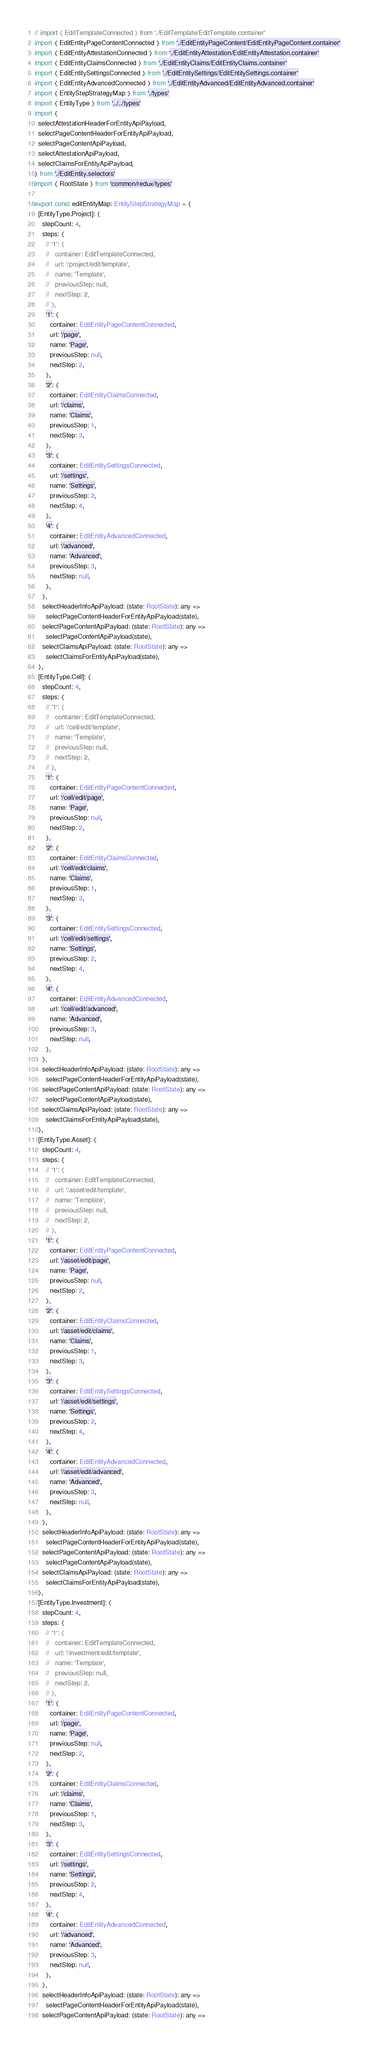<code> <loc_0><loc_0><loc_500><loc_500><_TypeScript_>// import { EditTemplateConnected } from './EditTemplate/EditTemplate.container'
import { EditEntityPageContentConnected } from './EditEntityPageContent/EditEntityPageContent.container'
import { EditEntityAttestationConnected } from './EditEntityAttestation/EditEntityAttestation.container'
import { EditEntityClaimsConnected } from './EditEntityClaims/EditEntityClaims.container'
import { EditEntitySettingsConnected } from './EditEntitySettings/EditEntitySettings.container'
import { EditEntityAdvancedConnected } from './EditEntityAdvanced/EditEntityAdvanced.container'
import { EntityStepStrategyMap } from './types'
import { EntityType } from '../../types'
import {
  selectAttestationHeaderForEntityApiPayload,
  selectPageContentHeaderForEntityApiPayload,
  selectPageContentApiPayload,
  selectAttestationApiPayload,
  selectClaimsForEntityApiPayload,
} from './EditEntity.selectors'
import { RootState } from 'common/redux/types'

export const editEntityMap: EntityStepStrategyMap = {
  [EntityType.Project]: {
    stepCount: 4,
    steps: {
      // '1': {
      //   container: EditTemplateConnected,
      //   url: '/project/edit/template',
      //   name: 'Template',
      //   previousStep: null,
      //   nextStep: 2,
      // },
      '1': {
        container: EditEntityPageContentConnected,
        url: '/page',
        name: 'Page',
        previousStep: null,
        nextStep: 2,
      },
      '2': {
        container: EditEntityClaimsConnected,
        url: '/claims',
        name: 'Claims',
        previousStep: 1,
        nextStep: 3,
      },
      '3': {
        container: EditEntitySettingsConnected,
        url: '/settings',
        name: 'Settings',
        previousStep: 2,
        nextStep: 4,
      },
      '4': {
        container: EditEntityAdvancedConnected,
        url: '/advanced',
        name: 'Advanced',
        previousStep: 3,
        nextStep: null,
      },
    },
    selectHeaderInfoApiPayload: (state: RootState): any =>
      selectPageContentHeaderForEntityApiPayload(state),
    selectPageContentApiPayload: (state: RootState): any =>
      selectPageContentApiPayload(state),
    selectClaimsApiPayload: (state: RootState): any =>
      selectClaimsForEntityApiPayload(state),
  },
  [EntityType.Cell]: {
    stepCount: 4,
    steps: {
      // '1': {
      //   container: EditTemplateConnected,
      //   url: '/cell/edit/template',
      //   name: 'Template',
      //   previousStep: null,
      //   nextStep: 2,
      // },
      '1': {
        container: EditEntityPageContentConnected,
        url: '/cell/edit/page',
        name: 'Page',
        previousStep: null,
        nextStep: 2,
      },
      '2': {
        container: EditEntityClaimsConnected,
        url: '/cell/edit/claims',
        name: 'Claims',
        previousStep: 1,
        nextStep: 3,
      },
      '3': {
        container: EditEntitySettingsConnected,
        url: '/cell/edit/settings',
        name: 'Settings',
        previousStep: 2,
        nextStep: 4,
      },
      '4': {
        container: EditEntityAdvancedConnected,
        url: '/cell/edit/advanced',
        name: 'Advanced',
        previousStep: 3,
        nextStep: null,
      },
    },
    selectHeaderInfoApiPayload: (state: RootState): any =>
      selectPageContentHeaderForEntityApiPayload(state),
    selectPageContentApiPayload: (state: RootState): any =>
      selectPageContentApiPayload(state),
    selectClaimsApiPayload: (state: RootState): any =>
      selectClaimsForEntityApiPayload(state),
  },
  [EntityType.Asset]: {
    stepCount: 4,
    steps: {
      // '1': {
      //   container: EditTemplateConnected,
      //   url: '/asset/edit/template',
      //   name: 'Template',
      //   previousStep: null,
      //   nextStep: 2,
      // },
      '1': {
        container: EditEntityPageContentConnected,
        url: '/asset/edit/page',
        name: 'Page',
        previousStep: null,
        nextStep: 2,
      },
      '2': {
        container: EditEntityClaimsConnected,
        url: '/asset/edit/claims',
        name: 'Claims',
        previousStep: 1,
        nextStep: 3,
      },
      '3': {
        container: EditEntitySettingsConnected,
        url: '/asset/edit/settings',
        name: 'Settings',
        previousStep: 2,
        nextStep: 4,
      },
      '4': {
        container: EditEntityAdvancedConnected,
        url: '/asset/edit/advanced',
        name: 'Advanced',
        previousStep: 3,
        nextStep: null,
      },
    },
    selectHeaderInfoApiPayload: (state: RootState): any =>
      selectPageContentHeaderForEntityApiPayload(state),
    selectPageContentApiPayload: (state: RootState): any =>
      selectPageContentApiPayload(state),
    selectClaimsApiPayload: (state: RootState): any =>
      selectClaimsForEntityApiPayload(state),
  },
  [EntityType.Investment]: {
    stepCount: 4,
    steps: {
      // '1': {
      //   container: EditTemplateConnected,
      //   url: '/investment/edit/template',
      //   name: 'Template',
      //   previousStep: null,
      //   nextStep: 2,
      // },
      '1': {
        container: EditEntityPageContentConnected,
        url: '/page',
        name: 'Page',
        previousStep: null,
        nextStep: 2,
      },
      '2': {
        container: EditEntityClaimsConnected,
        url: '/claims',
        name: 'Claims',
        previousStep: 1,
        nextStep: 3,
      },
      '3': {
        container: EditEntitySettingsConnected,
        url: '/settings',
        name: 'Settings',
        previousStep: 2,
        nextStep: 4,
      },
      '4': {
        container: EditEntityAdvancedConnected,
        url: '/advanced',
        name: 'Advanced',
        previousStep: 3,
        nextStep: null,
      },
    },
    selectHeaderInfoApiPayload: (state: RootState): any =>
      selectPageContentHeaderForEntityApiPayload(state),
    selectPageContentApiPayload: (state: RootState): any =></code> 